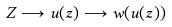Convert formula to latex. <formula><loc_0><loc_0><loc_500><loc_500>Z \longrightarrow u ( z ) \longrightarrow w ( u ( z ) )</formula> 